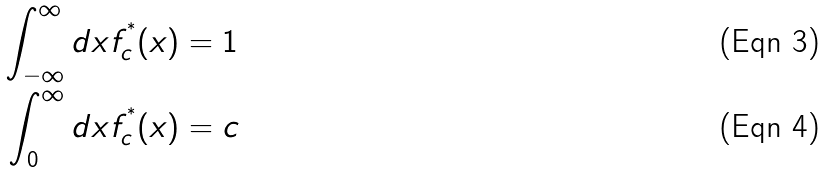<formula> <loc_0><loc_0><loc_500><loc_500>\int _ { - \infty } ^ { \infty } d x f _ { c } ^ { ^ { * } } ( x ) & = 1 \\ \int _ { 0 } ^ { \infty } d x f _ { c } ^ { ^ { * } } ( x ) & = c</formula> 